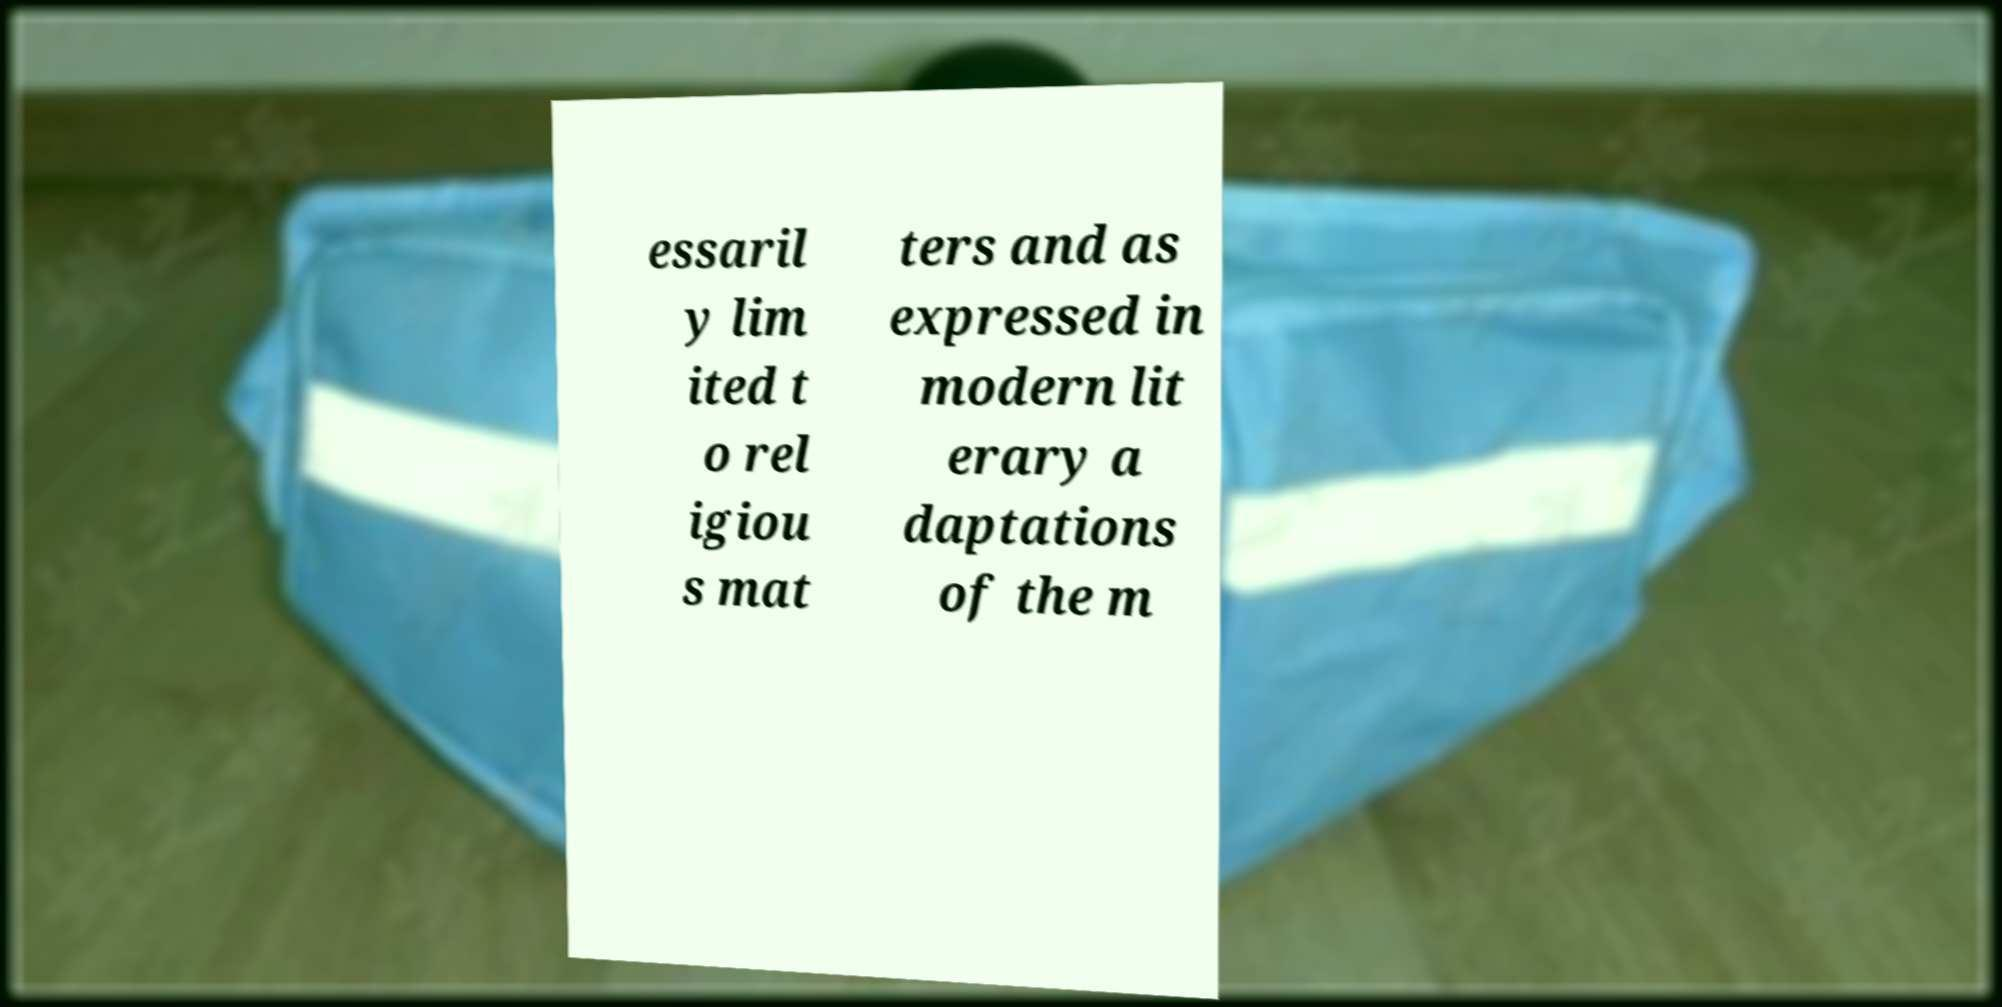I need the written content from this picture converted into text. Can you do that? essaril y lim ited t o rel igiou s mat ters and as expressed in modern lit erary a daptations of the m 